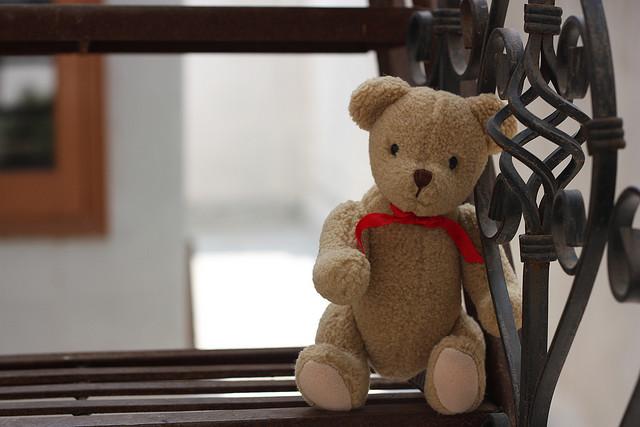Is the door in the background open?
Short answer required. Yes. What is the material he is leaning against?
Quick response, please. Metal. What is the bear sitting on?
Give a very brief answer. Bench. What color is the chair?
Write a very short answer. Brown. What color is the stuffed animal's nose?
Give a very brief answer. Brown. What type of bear is this?
Short answer required. Teddy. What is on the wall in the background?
Write a very short answer. Picture. Do the toys look new?
Short answer required. Yes. Is the teddy bear in a train?
Concise answer only. No. What animal is this?
Short answer required. Teddy bear. What is the chair made of?
Answer briefly. Metal. What color is the bench?
Keep it brief. Black. 